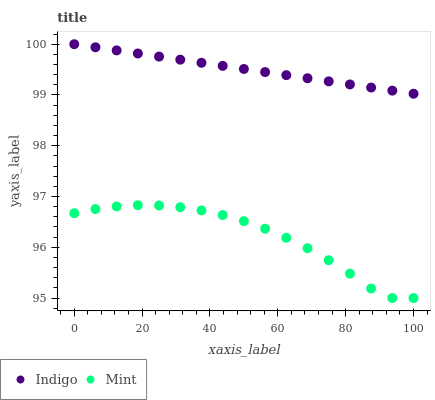Does Mint have the minimum area under the curve?
Answer yes or no. Yes. Does Indigo have the maximum area under the curve?
Answer yes or no. Yes. Does Indigo have the minimum area under the curve?
Answer yes or no. No. Is Indigo the smoothest?
Answer yes or no. Yes. Is Mint the roughest?
Answer yes or no. Yes. Is Indigo the roughest?
Answer yes or no. No. Does Mint have the lowest value?
Answer yes or no. Yes. Does Indigo have the lowest value?
Answer yes or no. No. Does Indigo have the highest value?
Answer yes or no. Yes. Is Mint less than Indigo?
Answer yes or no. Yes. Is Indigo greater than Mint?
Answer yes or no. Yes. Does Mint intersect Indigo?
Answer yes or no. No. 